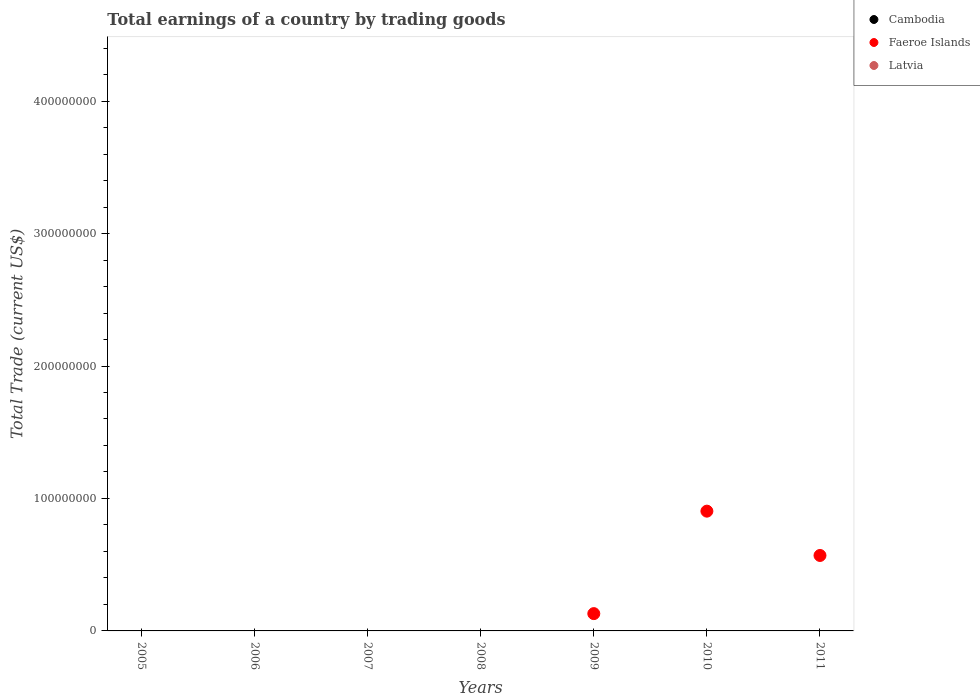How many different coloured dotlines are there?
Give a very brief answer. 1. Is the number of dotlines equal to the number of legend labels?
Offer a terse response. No. What is the total earnings in Faeroe Islands in 2008?
Your response must be concise. 0. Across all years, what is the maximum total earnings in Faeroe Islands?
Make the answer very short. 9.04e+07. In which year was the total earnings in Faeroe Islands maximum?
Your response must be concise. 2010. What is the total total earnings in Faeroe Islands in the graph?
Your response must be concise. 1.60e+08. What is the difference between the total earnings in Cambodia in 2011 and the total earnings in Latvia in 2009?
Keep it short and to the point. 0. What is the average total earnings in Latvia per year?
Ensure brevity in your answer.  0. What is the difference between the highest and the second highest total earnings in Faeroe Islands?
Your answer should be compact. 3.35e+07. What is the difference between the highest and the lowest total earnings in Faeroe Islands?
Your answer should be very brief. 9.04e+07. Does the total earnings in Cambodia monotonically increase over the years?
Your answer should be compact. No. How many dotlines are there?
Your answer should be very brief. 1. How many years are there in the graph?
Provide a succinct answer. 7. What is the difference between two consecutive major ticks on the Y-axis?
Offer a very short reply. 1.00e+08. Are the values on the major ticks of Y-axis written in scientific E-notation?
Provide a succinct answer. No. Does the graph contain any zero values?
Ensure brevity in your answer.  Yes. Where does the legend appear in the graph?
Keep it short and to the point. Top right. How many legend labels are there?
Offer a terse response. 3. How are the legend labels stacked?
Ensure brevity in your answer.  Vertical. What is the title of the graph?
Offer a terse response. Total earnings of a country by trading goods. What is the label or title of the X-axis?
Offer a terse response. Years. What is the label or title of the Y-axis?
Provide a short and direct response. Total Trade (current US$). What is the Total Trade (current US$) of Latvia in 2005?
Provide a short and direct response. 0. What is the Total Trade (current US$) in Cambodia in 2006?
Provide a short and direct response. 0. What is the Total Trade (current US$) in Latvia in 2006?
Provide a short and direct response. 0. What is the Total Trade (current US$) of Cambodia in 2007?
Your answer should be very brief. 0. What is the Total Trade (current US$) of Faeroe Islands in 2009?
Provide a short and direct response. 1.31e+07. What is the Total Trade (current US$) in Latvia in 2009?
Make the answer very short. 0. What is the Total Trade (current US$) of Cambodia in 2010?
Your answer should be compact. 0. What is the Total Trade (current US$) of Faeroe Islands in 2010?
Your answer should be very brief. 9.04e+07. What is the Total Trade (current US$) in Faeroe Islands in 2011?
Offer a terse response. 5.70e+07. Across all years, what is the maximum Total Trade (current US$) of Faeroe Islands?
Offer a terse response. 9.04e+07. What is the total Total Trade (current US$) of Cambodia in the graph?
Provide a succinct answer. 0. What is the total Total Trade (current US$) of Faeroe Islands in the graph?
Offer a very short reply. 1.60e+08. What is the total Total Trade (current US$) of Latvia in the graph?
Keep it short and to the point. 0. What is the difference between the Total Trade (current US$) in Faeroe Islands in 2009 and that in 2010?
Give a very brief answer. -7.74e+07. What is the difference between the Total Trade (current US$) in Faeroe Islands in 2009 and that in 2011?
Make the answer very short. -4.39e+07. What is the difference between the Total Trade (current US$) in Faeroe Islands in 2010 and that in 2011?
Your answer should be very brief. 3.35e+07. What is the average Total Trade (current US$) in Cambodia per year?
Your answer should be very brief. 0. What is the average Total Trade (current US$) in Faeroe Islands per year?
Offer a very short reply. 2.29e+07. What is the average Total Trade (current US$) in Latvia per year?
Offer a very short reply. 0. What is the ratio of the Total Trade (current US$) of Faeroe Islands in 2009 to that in 2010?
Your answer should be compact. 0.14. What is the ratio of the Total Trade (current US$) in Faeroe Islands in 2009 to that in 2011?
Offer a terse response. 0.23. What is the ratio of the Total Trade (current US$) in Faeroe Islands in 2010 to that in 2011?
Provide a short and direct response. 1.59. What is the difference between the highest and the second highest Total Trade (current US$) in Faeroe Islands?
Offer a terse response. 3.35e+07. What is the difference between the highest and the lowest Total Trade (current US$) of Faeroe Islands?
Give a very brief answer. 9.04e+07. 